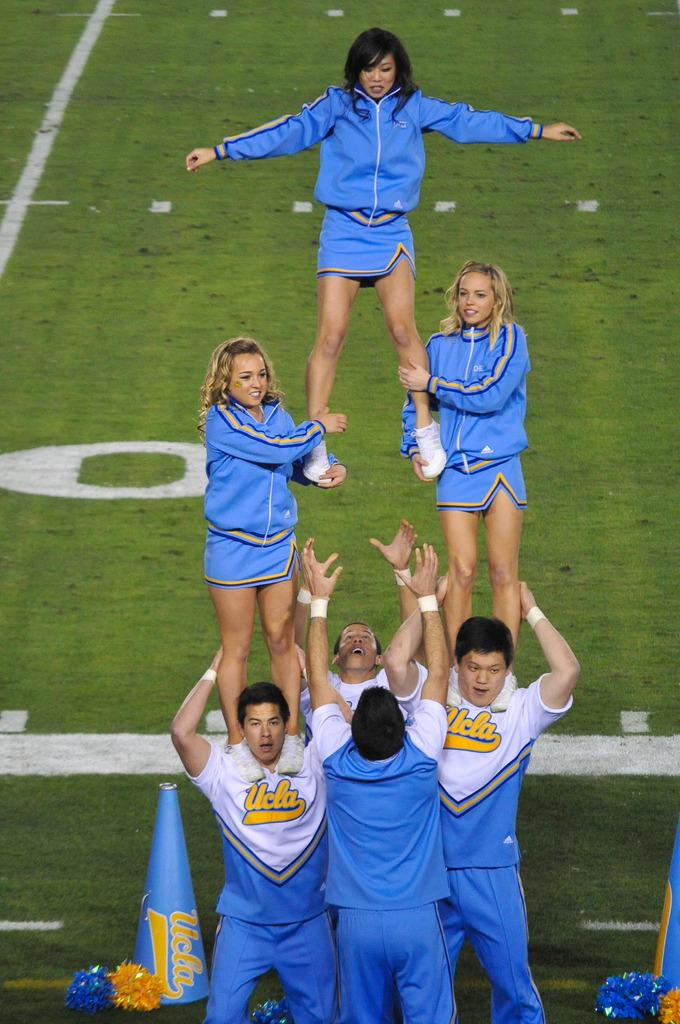<image>
Write a terse but informative summary of the picture. team members for Ucla holding up a squad of cheerleaders 